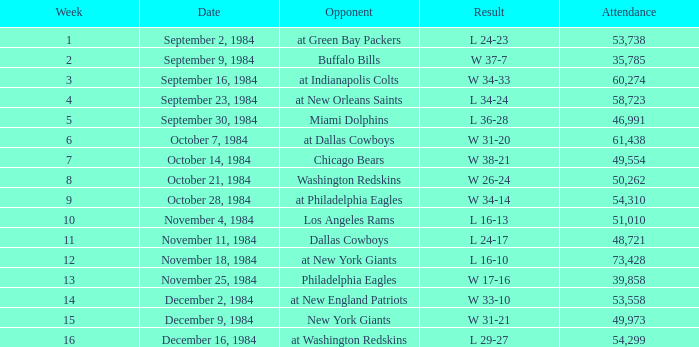What was the outcome in a week under 10 against the chicago bears' opponent? W 38-21. 